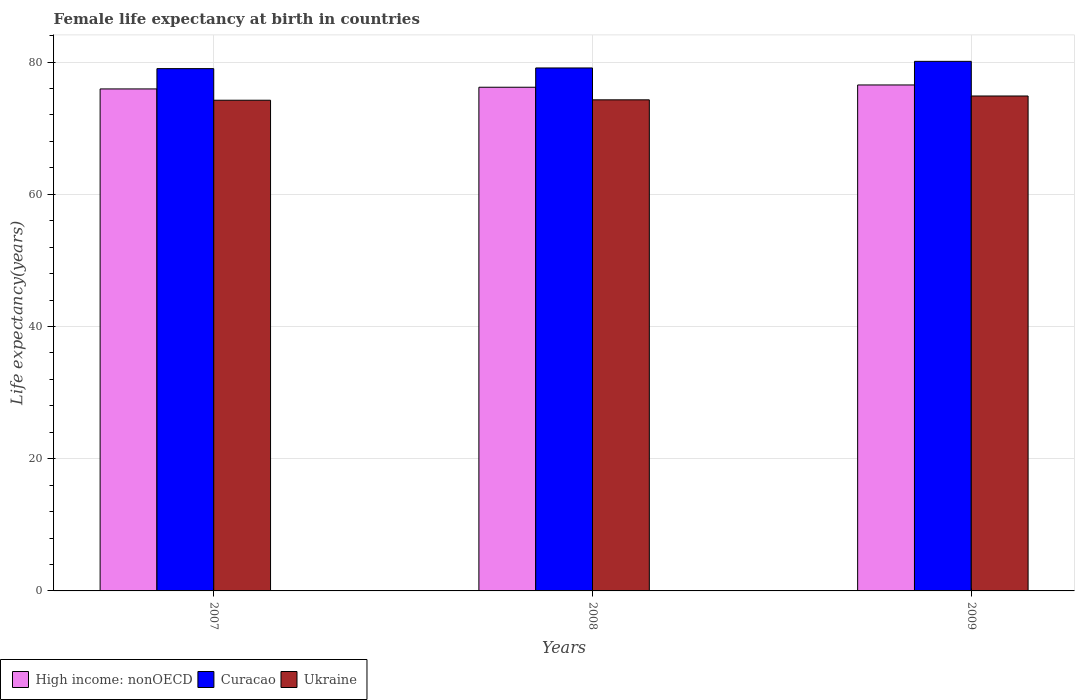How many groups of bars are there?
Give a very brief answer. 3. Are the number of bars on each tick of the X-axis equal?
Offer a terse response. Yes. How many bars are there on the 2nd tick from the right?
Give a very brief answer. 3. What is the label of the 3rd group of bars from the left?
Your answer should be compact. 2009. What is the female life expectancy at birth in Ukraine in 2007?
Make the answer very short. 74.22. Across all years, what is the maximum female life expectancy at birth in Curacao?
Make the answer very short. 80.1. Across all years, what is the minimum female life expectancy at birth in Ukraine?
Provide a succinct answer. 74.22. In which year was the female life expectancy at birth in Ukraine maximum?
Ensure brevity in your answer.  2009. In which year was the female life expectancy at birth in Ukraine minimum?
Your answer should be very brief. 2007. What is the total female life expectancy at birth in High income: nonOECD in the graph?
Give a very brief answer. 228.64. What is the difference between the female life expectancy at birth in Ukraine in 2008 and that in 2009?
Provide a succinct answer. -0.58. What is the difference between the female life expectancy at birth in High income: nonOECD in 2008 and the female life expectancy at birth in Ukraine in 2009?
Your response must be concise. 1.32. What is the average female life expectancy at birth in Ukraine per year?
Keep it short and to the point. 74.45. In the year 2009, what is the difference between the female life expectancy at birth in Ukraine and female life expectancy at birth in High income: nonOECD?
Your answer should be very brief. -1.67. In how many years, is the female life expectancy at birth in High income: nonOECD greater than 68 years?
Give a very brief answer. 3. What is the ratio of the female life expectancy at birth in High income: nonOECD in 2008 to that in 2009?
Make the answer very short. 1. What is the difference between the highest and the second highest female life expectancy at birth in Curacao?
Provide a short and direct response. 1. What is the difference between the highest and the lowest female life expectancy at birth in Curacao?
Give a very brief answer. 1.1. What does the 2nd bar from the left in 2007 represents?
Give a very brief answer. Curacao. What does the 2nd bar from the right in 2008 represents?
Provide a short and direct response. Curacao. Is it the case that in every year, the sum of the female life expectancy at birth in Ukraine and female life expectancy at birth in High income: nonOECD is greater than the female life expectancy at birth in Curacao?
Your answer should be very brief. Yes. How many bars are there?
Provide a succinct answer. 9. What is the difference between two consecutive major ticks on the Y-axis?
Provide a succinct answer. 20. Are the values on the major ticks of Y-axis written in scientific E-notation?
Keep it short and to the point. No. Does the graph contain any zero values?
Ensure brevity in your answer.  No. Where does the legend appear in the graph?
Keep it short and to the point. Bottom left. How many legend labels are there?
Ensure brevity in your answer.  3. How are the legend labels stacked?
Offer a very short reply. Horizontal. What is the title of the graph?
Ensure brevity in your answer.  Female life expectancy at birth in countries. What is the label or title of the X-axis?
Offer a terse response. Years. What is the label or title of the Y-axis?
Offer a terse response. Life expectancy(years). What is the Life expectancy(years) of High income: nonOECD in 2007?
Make the answer very short. 75.93. What is the Life expectancy(years) of Curacao in 2007?
Offer a very short reply. 79. What is the Life expectancy(years) of Ukraine in 2007?
Provide a succinct answer. 74.22. What is the Life expectancy(years) in High income: nonOECD in 2008?
Provide a short and direct response. 76.18. What is the Life expectancy(years) of Curacao in 2008?
Provide a short and direct response. 79.1. What is the Life expectancy(years) of Ukraine in 2008?
Ensure brevity in your answer.  74.28. What is the Life expectancy(years) in High income: nonOECD in 2009?
Provide a short and direct response. 76.53. What is the Life expectancy(years) in Curacao in 2009?
Keep it short and to the point. 80.1. What is the Life expectancy(years) of Ukraine in 2009?
Offer a very short reply. 74.86. Across all years, what is the maximum Life expectancy(years) in High income: nonOECD?
Ensure brevity in your answer.  76.53. Across all years, what is the maximum Life expectancy(years) of Curacao?
Your response must be concise. 80.1. Across all years, what is the maximum Life expectancy(years) in Ukraine?
Offer a terse response. 74.86. Across all years, what is the minimum Life expectancy(years) in High income: nonOECD?
Provide a succinct answer. 75.93. Across all years, what is the minimum Life expectancy(years) in Curacao?
Make the answer very short. 79. Across all years, what is the minimum Life expectancy(years) of Ukraine?
Offer a terse response. 74.22. What is the total Life expectancy(years) in High income: nonOECD in the graph?
Keep it short and to the point. 228.64. What is the total Life expectancy(years) in Curacao in the graph?
Your answer should be compact. 238.2. What is the total Life expectancy(years) of Ukraine in the graph?
Your answer should be very brief. 223.36. What is the difference between the Life expectancy(years) of High income: nonOECD in 2007 and that in 2008?
Your response must be concise. -0.25. What is the difference between the Life expectancy(years) of Curacao in 2007 and that in 2008?
Offer a terse response. -0.1. What is the difference between the Life expectancy(years) of Ukraine in 2007 and that in 2008?
Ensure brevity in your answer.  -0.06. What is the difference between the Life expectancy(years) of High income: nonOECD in 2007 and that in 2009?
Your response must be concise. -0.6. What is the difference between the Life expectancy(years) of Ukraine in 2007 and that in 2009?
Your response must be concise. -0.64. What is the difference between the Life expectancy(years) of High income: nonOECD in 2008 and that in 2009?
Keep it short and to the point. -0.34. What is the difference between the Life expectancy(years) in Ukraine in 2008 and that in 2009?
Provide a succinct answer. -0.58. What is the difference between the Life expectancy(years) in High income: nonOECD in 2007 and the Life expectancy(years) in Curacao in 2008?
Provide a short and direct response. -3.17. What is the difference between the Life expectancy(years) in High income: nonOECD in 2007 and the Life expectancy(years) in Ukraine in 2008?
Your answer should be very brief. 1.65. What is the difference between the Life expectancy(years) of Curacao in 2007 and the Life expectancy(years) of Ukraine in 2008?
Give a very brief answer. 4.72. What is the difference between the Life expectancy(years) of High income: nonOECD in 2007 and the Life expectancy(years) of Curacao in 2009?
Offer a terse response. -4.17. What is the difference between the Life expectancy(years) in High income: nonOECD in 2007 and the Life expectancy(years) in Ukraine in 2009?
Make the answer very short. 1.07. What is the difference between the Life expectancy(years) of Curacao in 2007 and the Life expectancy(years) of Ukraine in 2009?
Ensure brevity in your answer.  4.14. What is the difference between the Life expectancy(years) of High income: nonOECD in 2008 and the Life expectancy(years) of Curacao in 2009?
Make the answer very short. -3.92. What is the difference between the Life expectancy(years) of High income: nonOECD in 2008 and the Life expectancy(years) of Ukraine in 2009?
Your response must be concise. 1.32. What is the difference between the Life expectancy(years) of Curacao in 2008 and the Life expectancy(years) of Ukraine in 2009?
Your answer should be compact. 4.24. What is the average Life expectancy(years) in High income: nonOECD per year?
Ensure brevity in your answer.  76.21. What is the average Life expectancy(years) of Curacao per year?
Your answer should be compact. 79.4. What is the average Life expectancy(years) of Ukraine per year?
Keep it short and to the point. 74.45. In the year 2007, what is the difference between the Life expectancy(years) in High income: nonOECD and Life expectancy(years) in Curacao?
Your answer should be very brief. -3.07. In the year 2007, what is the difference between the Life expectancy(years) in High income: nonOECD and Life expectancy(years) in Ukraine?
Make the answer very short. 1.71. In the year 2007, what is the difference between the Life expectancy(years) in Curacao and Life expectancy(years) in Ukraine?
Your answer should be very brief. 4.78. In the year 2008, what is the difference between the Life expectancy(years) of High income: nonOECD and Life expectancy(years) of Curacao?
Keep it short and to the point. -2.92. In the year 2008, what is the difference between the Life expectancy(years) of High income: nonOECD and Life expectancy(years) of Ukraine?
Your answer should be compact. 1.9. In the year 2008, what is the difference between the Life expectancy(years) of Curacao and Life expectancy(years) of Ukraine?
Provide a short and direct response. 4.82. In the year 2009, what is the difference between the Life expectancy(years) in High income: nonOECD and Life expectancy(years) in Curacao?
Make the answer very short. -3.57. In the year 2009, what is the difference between the Life expectancy(years) in High income: nonOECD and Life expectancy(years) in Ukraine?
Make the answer very short. 1.67. In the year 2009, what is the difference between the Life expectancy(years) in Curacao and Life expectancy(years) in Ukraine?
Provide a succinct answer. 5.24. What is the ratio of the Life expectancy(years) in High income: nonOECD in 2007 to that in 2008?
Your response must be concise. 1. What is the ratio of the Life expectancy(years) of Ukraine in 2007 to that in 2008?
Your answer should be compact. 1. What is the ratio of the Life expectancy(years) of Curacao in 2007 to that in 2009?
Offer a very short reply. 0.99. What is the ratio of the Life expectancy(years) of Curacao in 2008 to that in 2009?
Your response must be concise. 0.99. What is the ratio of the Life expectancy(years) of Ukraine in 2008 to that in 2009?
Provide a short and direct response. 0.99. What is the difference between the highest and the second highest Life expectancy(years) of High income: nonOECD?
Your answer should be very brief. 0.34. What is the difference between the highest and the second highest Life expectancy(years) of Curacao?
Offer a very short reply. 1. What is the difference between the highest and the second highest Life expectancy(years) of Ukraine?
Offer a terse response. 0.58. What is the difference between the highest and the lowest Life expectancy(years) of High income: nonOECD?
Provide a succinct answer. 0.6. What is the difference between the highest and the lowest Life expectancy(years) of Ukraine?
Provide a succinct answer. 0.64. 